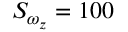Convert formula to latex. <formula><loc_0><loc_0><loc_500><loc_500>S _ { \omega _ { z } } = 1 0 0 \</formula> 